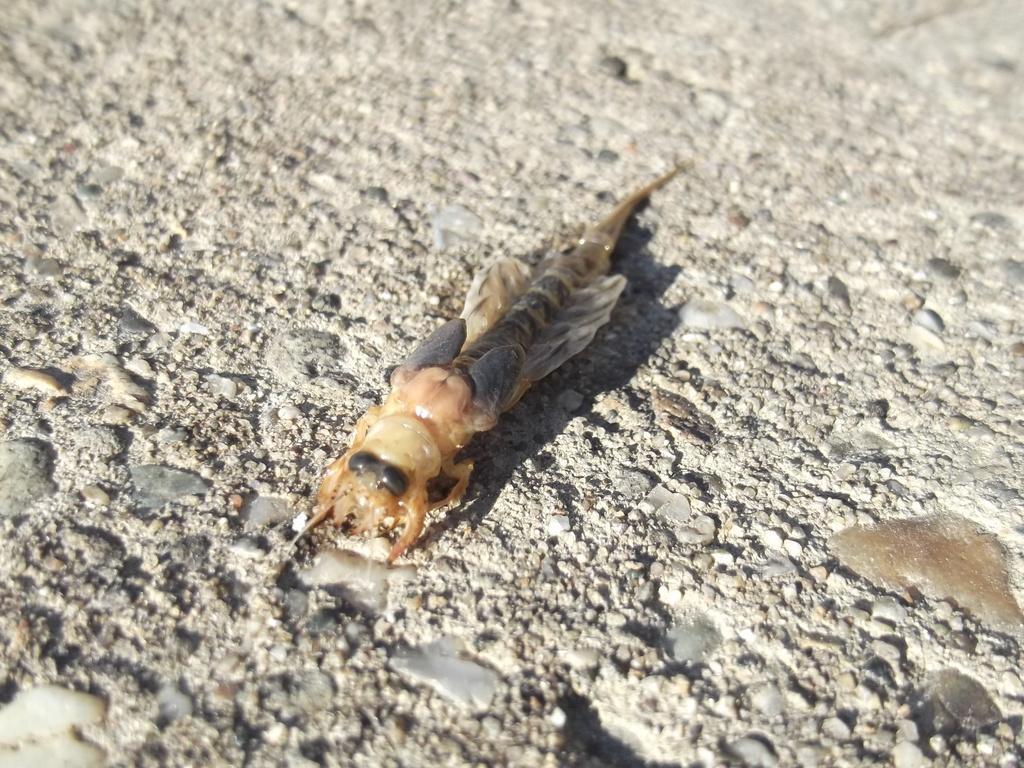Please provide a concise description of this image. There is one insect present on a ground surface as we can see in the middle of this image. 